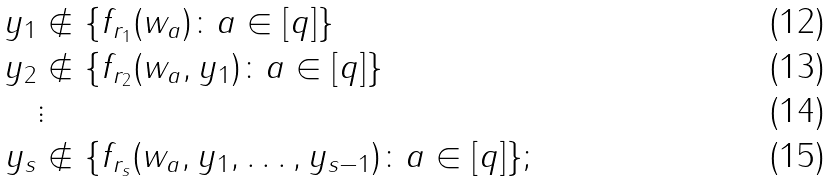Convert formula to latex. <formula><loc_0><loc_0><loc_500><loc_500>y _ { 1 } & \notin \{ f _ { r _ { 1 } } ( w _ { a } ) \colon a \in [ q ] \} \\ y _ { 2 } & \notin \{ f _ { r _ { 2 } } ( w _ { a } , y _ { 1 } ) \colon a \in [ q ] \} \\ & \vdots \\ y _ { s } & \notin \{ f _ { r _ { s } } ( w _ { a } , y _ { 1 } , \dots , y _ { s - 1 } ) \colon a \in [ q ] \} ;</formula> 